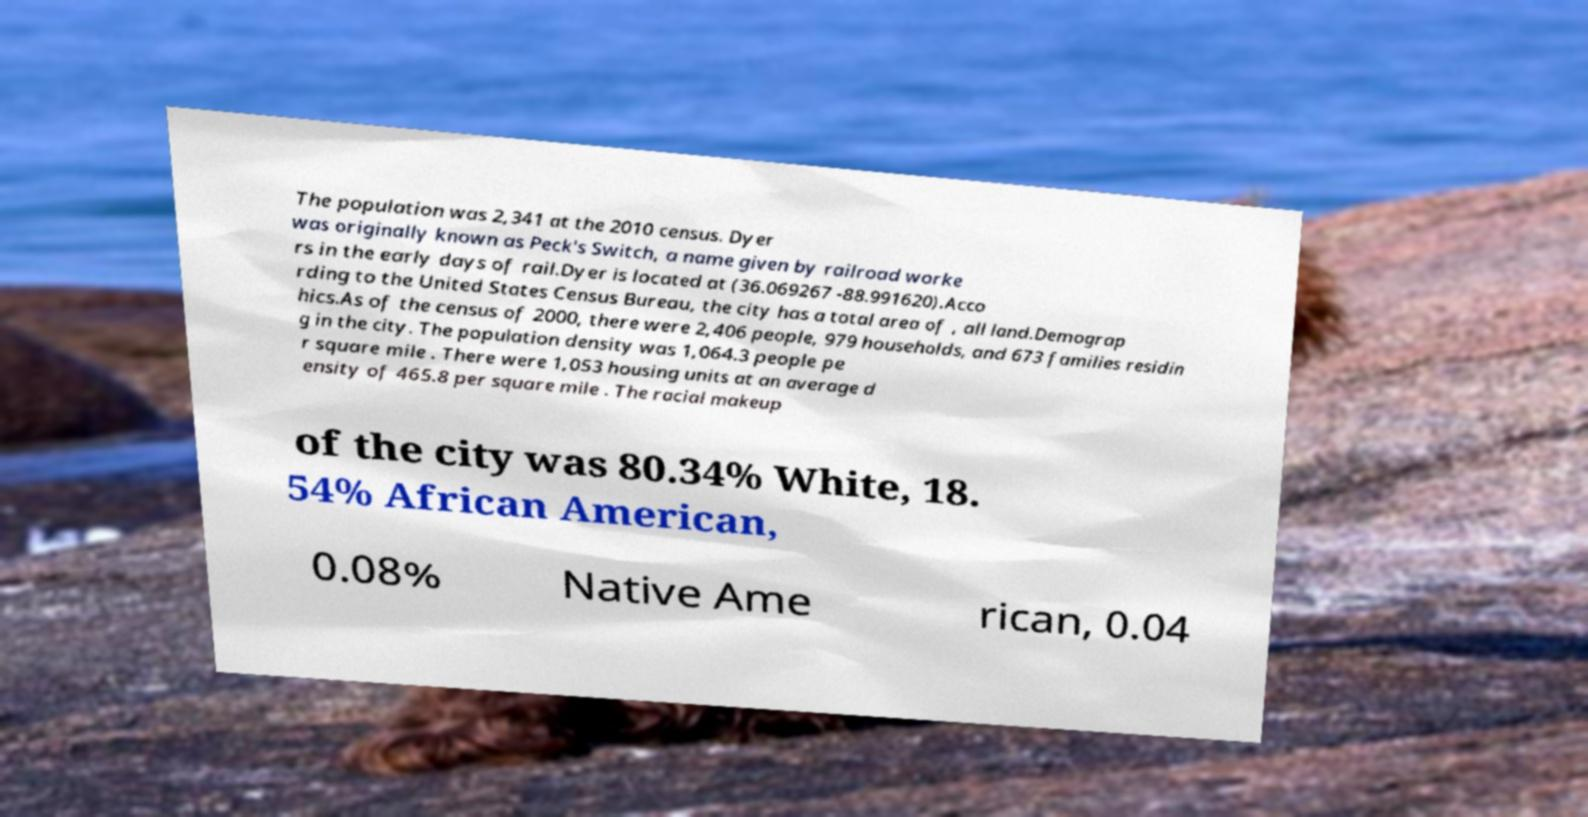What messages or text are displayed in this image? I need them in a readable, typed format. The population was 2,341 at the 2010 census. Dyer was originally known as Peck's Switch, a name given by railroad worke rs in the early days of rail.Dyer is located at (36.069267 -88.991620).Acco rding to the United States Census Bureau, the city has a total area of , all land.Demograp hics.As of the census of 2000, there were 2,406 people, 979 households, and 673 families residin g in the city. The population density was 1,064.3 people pe r square mile . There were 1,053 housing units at an average d ensity of 465.8 per square mile . The racial makeup of the city was 80.34% White, 18. 54% African American, 0.08% Native Ame rican, 0.04 